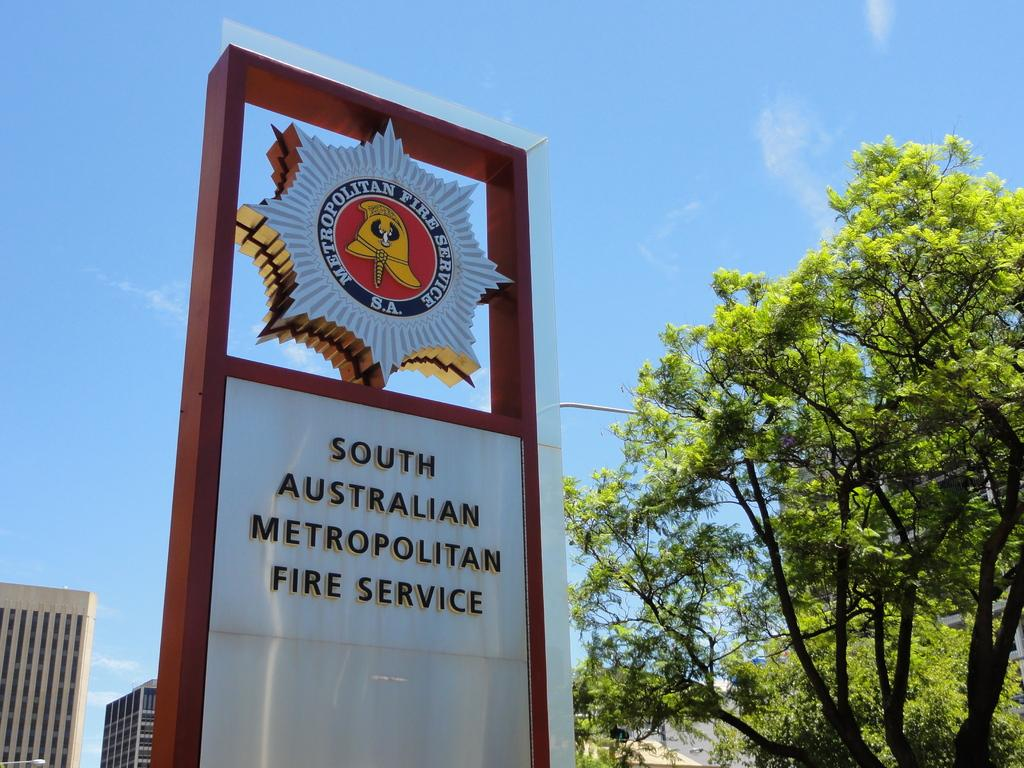What is the main subject of the picture? The main subject of the picture is an entrance board of a fire service office. What can be seen behind the board? There are two buildings behind the board. What type of vegetation is on the right side of the image? There are trees on the right side of the image. What type of blood is visible on the tramp's lunch in the image? There is no tramp or lunch present in the image, and therefore no blood can be observed. 